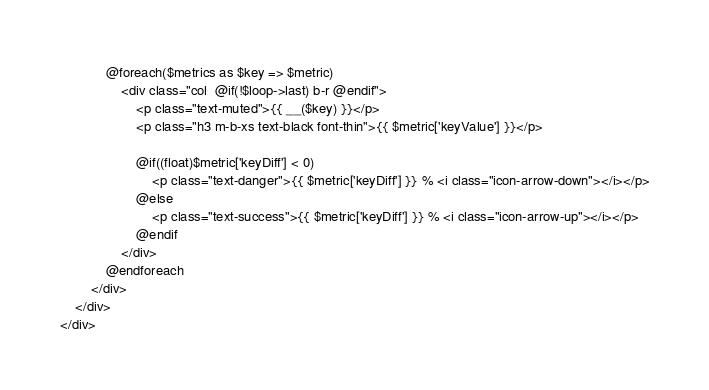Convert code to text. <code><loc_0><loc_0><loc_500><loc_500><_PHP_>            @foreach($metrics as $key => $metric)
                <div class="col  @if(!$loop->last) b-r @endif">
                    <p class="text-muted">{{ __($key) }}</p>
                    <p class="h3 m-b-xs text-black font-thin">{{ $metric['keyValue'] }}</p>

                    @if((float)$metric['keyDiff'] < 0)
                        <p class="text-danger">{{ $metric['keyDiff'] }} % <i class="icon-arrow-down"></i></p>
                    @else
                        <p class="text-success">{{ $metric['keyDiff'] }} % <i class="icon-arrow-up"></i></p>
                    @endif
                </div>
            @endforeach
        </div>
    </div>
</div></code> 